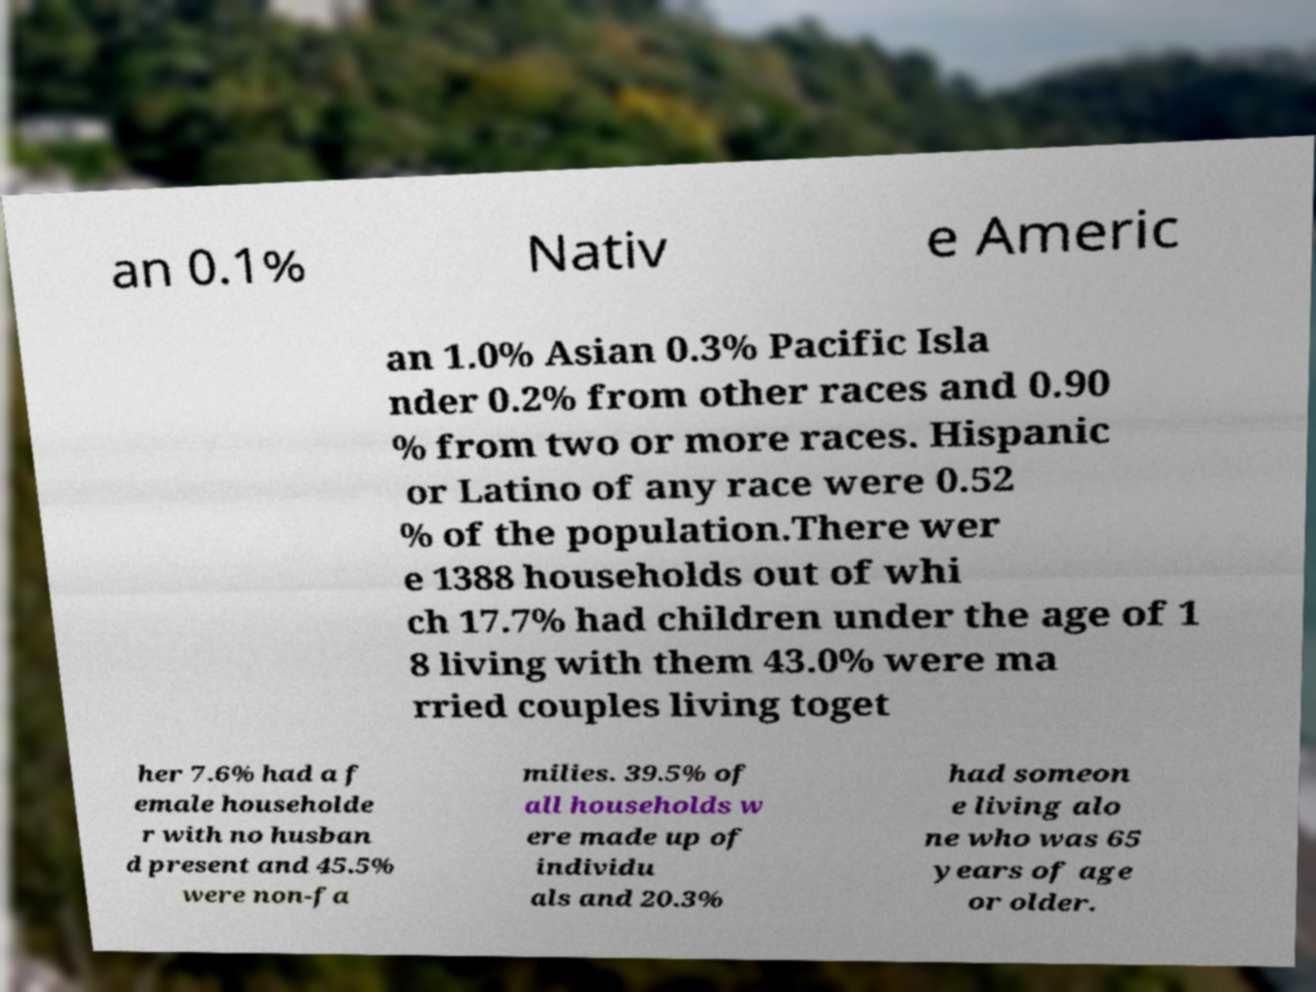Please read and relay the text visible in this image. What does it say? an 0.1% Nativ e Americ an 1.0% Asian 0.3% Pacific Isla nder 0.2% from other races and 0.90 % from two or more races. Hispanic or Latino of any race were 0.52 % of the population.There wer e 1388 households out of whi ch 17.7% had children under the age of 1 8 living with them 43.0% were ma rried couples living toget her 7.6% had a f emale householde r with no husban d present and 45.5% were non-fa milies. 39.5% of all households w ere made up of individu als and 20.3% had someon e living alo ne who was 65 years of age or older. 